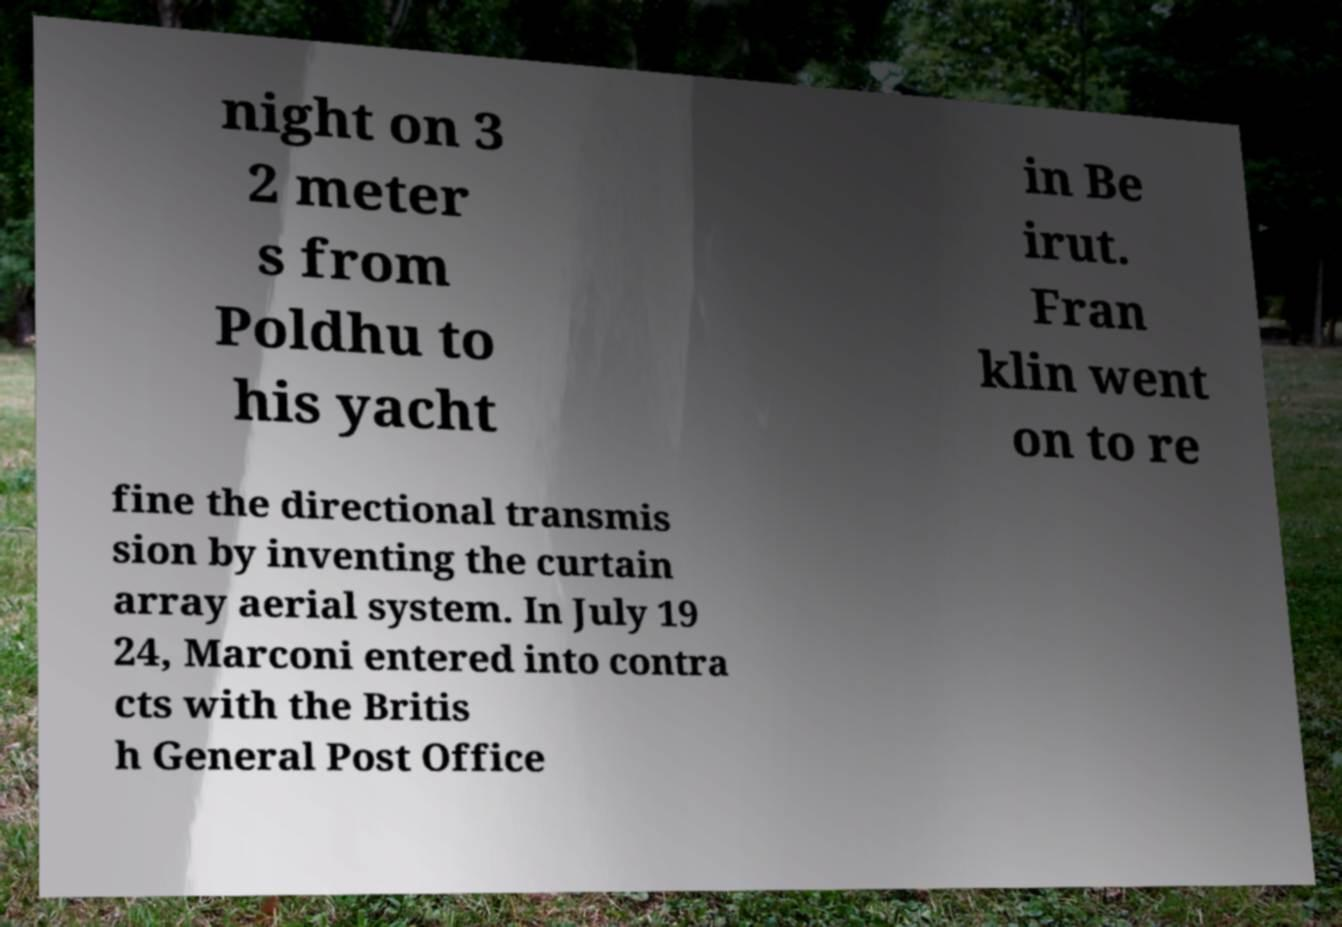There's text embedded in this image that I need extracted. Can you transcribe it verbatim? night on 3 2 meter s from Poldhu to his yacht in Be irut. Fran klin went on to re fine the directional transmis sion by inventing the curtain array aerial system. In July 19 24, Marconi entered into contra cts with the Britis h General Post Office 